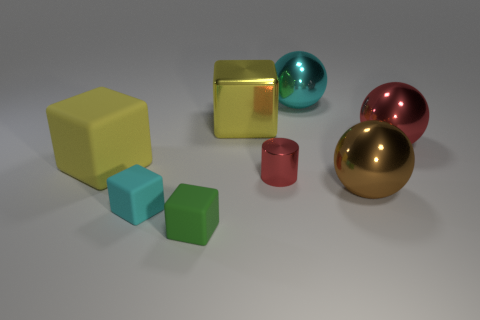How many big brown metallic balls are in front of the yellow matte thing?
Provide a succinct answer. 1. Are there fewer tiny red metallic things that are in front of the metal cylinder than big yellow things?
Give a very brief answer. Yes. The small shiny object is what color?
Your answer should be compact. Red. There is a block behind the large rubber thing; does it have the same color as the big rubber cube?
Ensure brevity in your answer.  Yes. The other tiny rubber object that is the same shape as the tiny cyan matte thing is what color?
Provide a short and direct response. Green. How many big objects are either brown spheres or yellow rubber cubes?
Make the answer very short. 2. What size is the cyan thing that is in front of the large red metallic object?
Make the answer very short. Small. Is there another block of the same color as the large metallic cube?
Offer a very short reply. Yes. Does the big rubber object have the same color as the large shiny cube?
Make the answer very short. Yes. The metallic object that is the same color as the small metallic cylinder is what shape?
Provide a short and direct response. Sphere. 